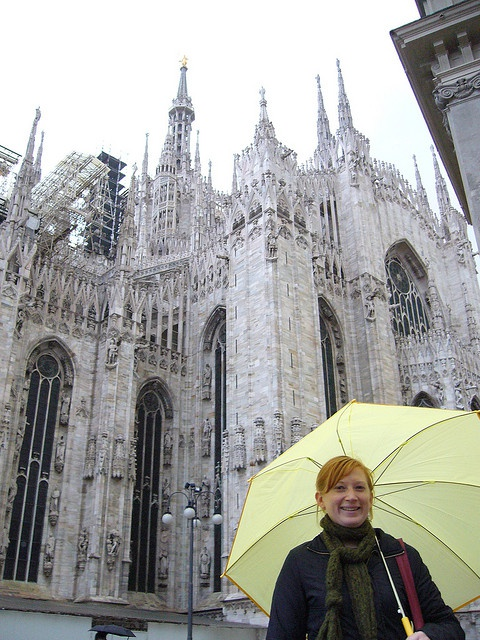Describe the objects in this image and their specific colors. I can see umbrella in white, khaki, lightyellow, and tan tones and people in white, black, maroon, olive, and gray tones in this image. 